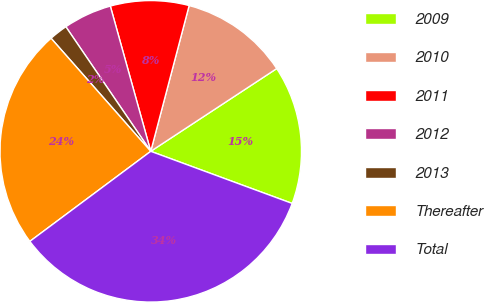<chart> <loc_0><loc_0><loc_500><loc_500><pie_chart><fcel>2009<fcel>2010<fcel>2011<fcel>2012<fcel>2013<fcel>Thereafter<fcel>Total<nl><fcel>14.87%<fcel>11.65%<fcel>8.42%<fcel>5.2%<fcel>1.98%<fcel>23.69%<fcel>34.19%<nl></chart> 